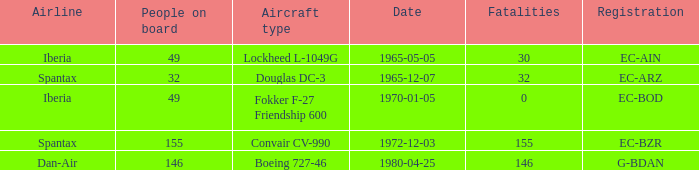How many fatalities are there for the airline of spantax, with a registration of ec-arz? 32.0. 